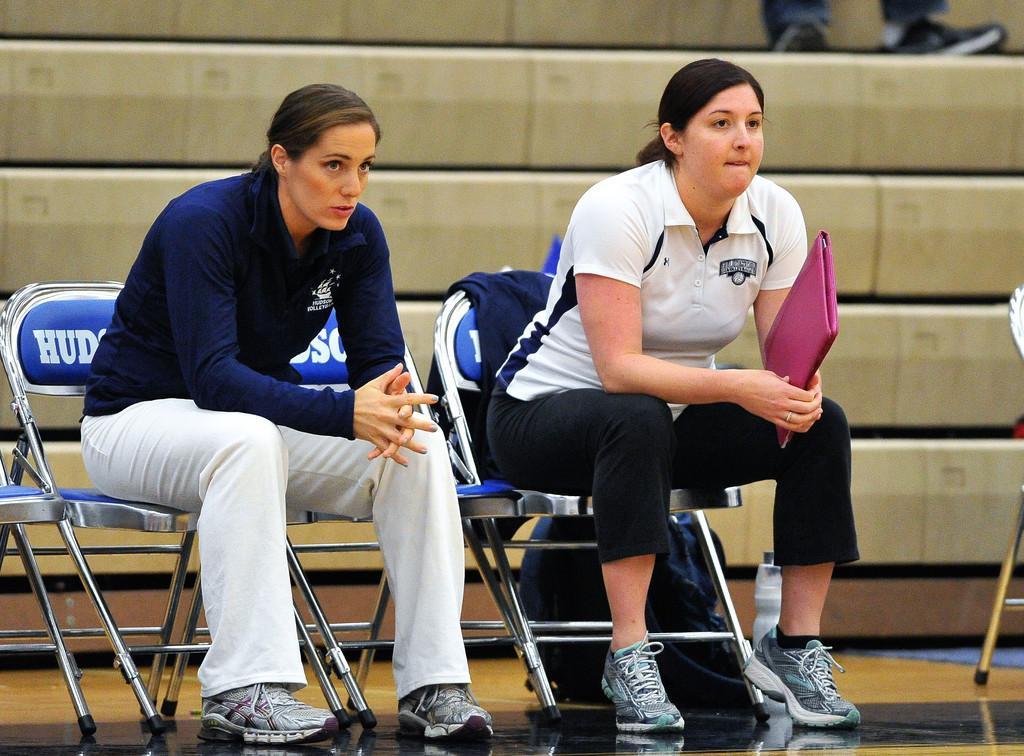How many people are in the image? There are two women in the image. What are the women doing in the image? The women are sitting on chairs. What is one of the women holding? One of the women is holding a file. What type of skirt is the sink wearing in the image? There is no sink or skirt present in the image. What point is the woman trying to make with her file? The image does not provide any information about the purpose or point of the woman holding the file. 